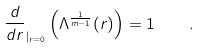<formula> <loc_0><loc_0><loc_500><loc_500>\frac { d } { d r } _ { | _ { r = 0 } } \left ( \Lambda ^ { \frac { 1 } { m - 1 } } ( r ) \right ) = 1 \quad .</formula> 